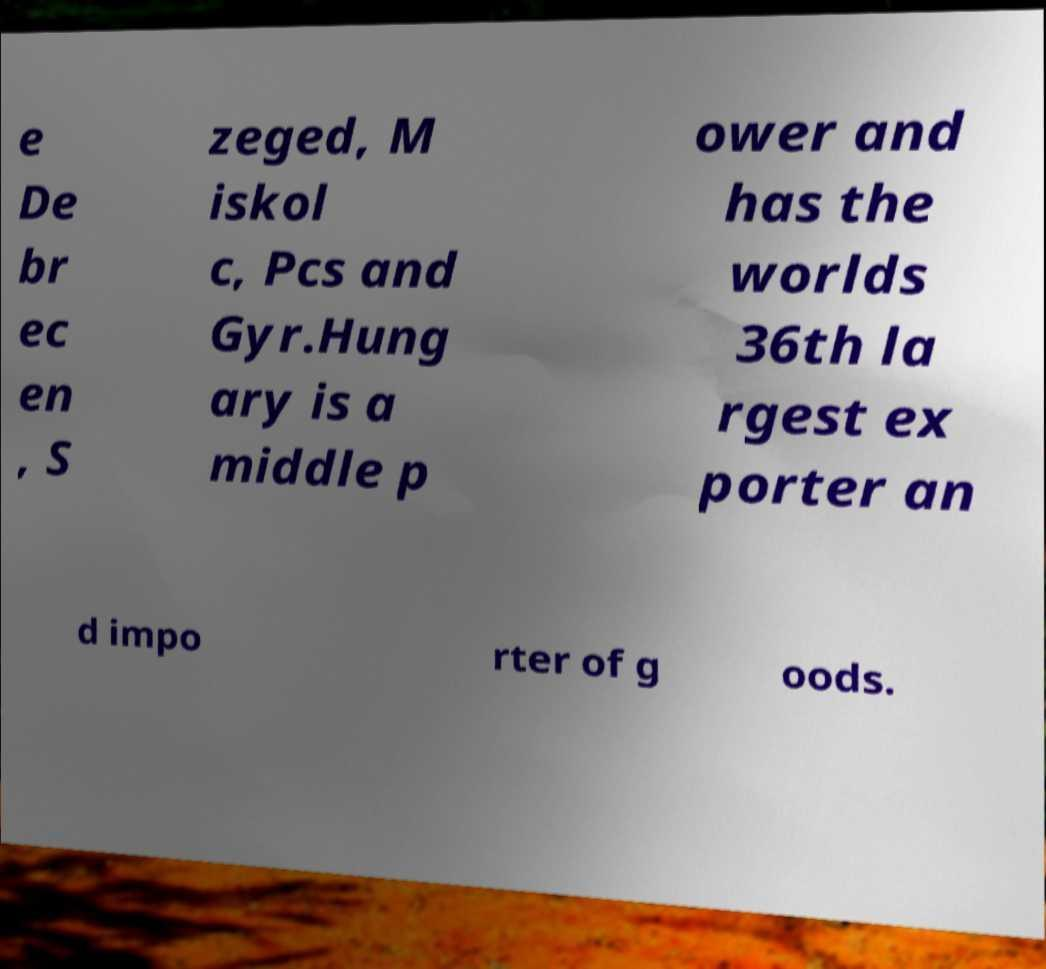Can you accurately transcribe the text from the provided image for me? e De br ec en , S zeged, M iskol c, Pcs and Gyr.Hung ary is a middle p ower and has the worlds 36th la rgest ex porter an d impo rter of g oods. 